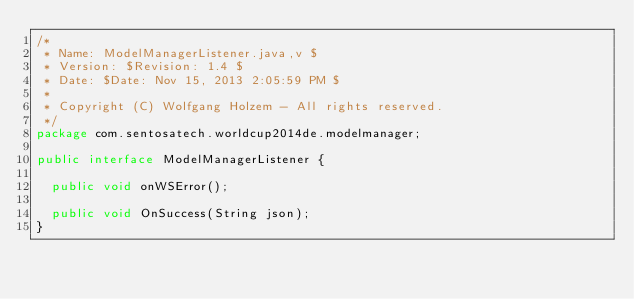Convert code to text. <code><loc_0><loc_0><loc_500><loc_500><_Java_>/*
 * Name: ModelManagerListener.java,v $
 * Version: $Revision: 1.4 $
 * Date: $Date: Nov 15, 2013 2:05:59 PM $
 *
 * Copyright (C) Wolfgang Holzem - All rights reserved.
 */
package com.sentosatech.worldcup2014de.modelmanager;

public interface ModelManagerListener {

	public void onWSError();

	public void OnSuccess(String json);
}
</code> 